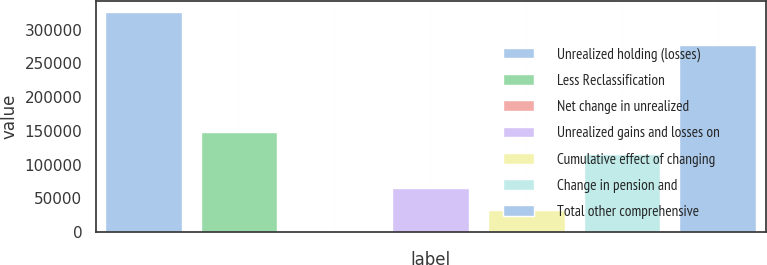Convert chart to OTSL. <chart><loc_0><loc_0><loc_500><loc_500><bar_chart><fcel>Unrealized holding (losses)<fcel>Less Reclassification<fcel>Net change in unrealized<fcel>Unrealized gains and losses on<fcel>Cumulative effect of changing<fcel>Change in pension and<fcel>Total other comprehensive<nl><fcel>325716<fcel>148128<fcel>319<fcel>65398.4<fcel>32858.7<fcel>115588<fcel>277082<nl></chart> 